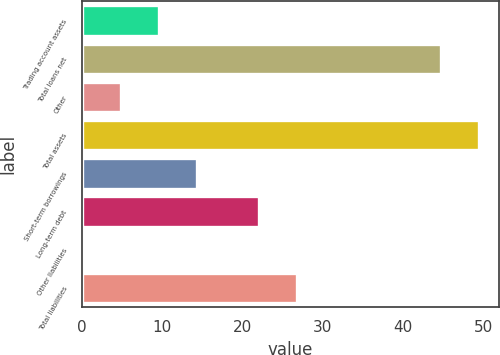Convert chart to OTSL. <chart><loc_0><loc_0><loc_500><loc_500><bar_chart><fcel>Trading account assets<fcel>Total loans net<fcel>Other<fcel>Total assets<fcel>Short-term borrowings<fcel>Long-term debt<fcel>Other liabilities<fcel>Total liabilities<nl><fcel>9.66<fcel>44.7<fcel>4.93<fcel>49.43<fcel>14.39<fcel>22.1<fcel>0.2<fcel>26.83<nl></chart> 